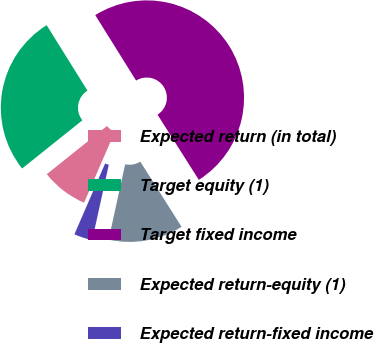Convert chart to OTSL. <chart><loc_0><loc_0><loc_500><loc_500><pie_chart><fcel>Expected return (in total)<fcel>Target equity (1)<fcel>Target fixed income<fcel>Expected return-equity (1)<fcel>Expected return-fixed income<nl><fcel>7.75%<fcel>26.86%<fcel>49.88%<fcel>12.43%<fcel>3.07%<nl></chart> 